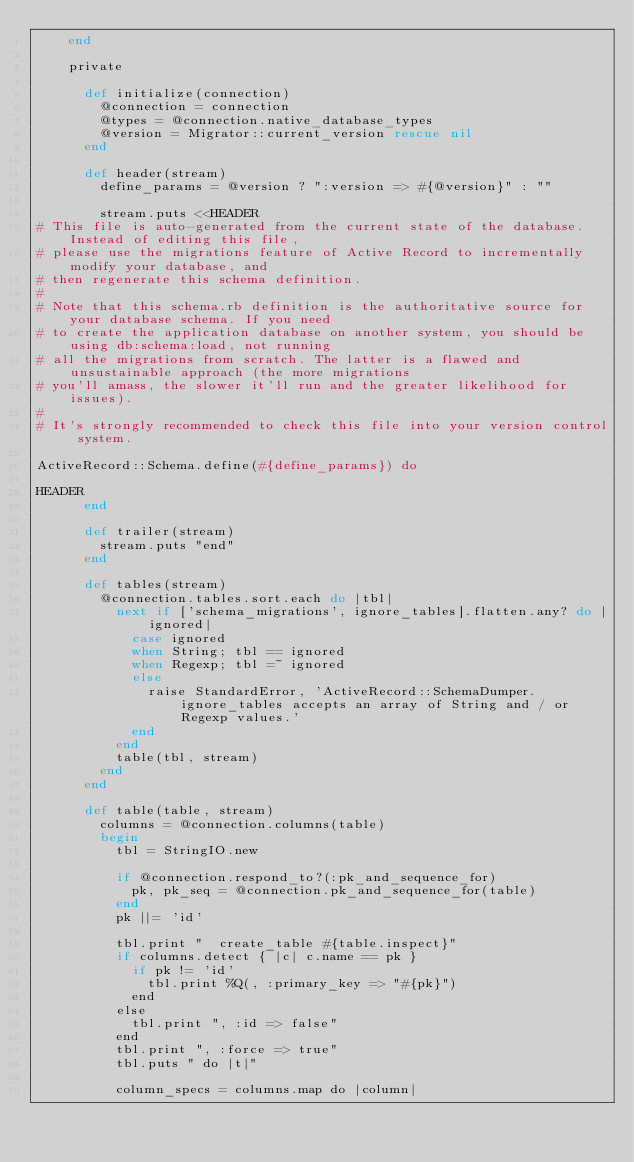Convert code to text. <code><loc_0><loc_0><loc_500><loc_500><_Ruby_>    end

    private

      def initialize(connection)
        @connection = connection
        @types = @connection.native_database_types
        @version = Migrator::current_version rescue nil
      end

      def header(stream)
        define_params = @version ? ":version => #{@version}" : ""

        stream.puts <<HEADER
# This file is auto-generated from the current state of the database. Instead of editing this file, 
# please use the migrations feature of Active Record to incrementally modify your database, and
# then regenerate this schema definition.
#
# Note that this schema.rb definition is the authoritative source for your database schema. If you need
# to create the application database on another system, you should be using db:schema:load, not running
# all the migrations from scratch. The latter is a flawed and unsustainable approach (the more migrations
# you'll amass, the slower it'll run and the greater likelihood for issues).
#
# It's strongly recommended to check this file into your version control system.

ActiveRecord::Schema.define(#{define_params}) do

HEADER
      end

      def trailer(stream)
        stream.puts "end"
      end

      def tables(stream)
        @connection.tables.sort.each do |tbl|
          next if ['schema_migrations', ignore_tables].flatten.any? do |ignored|
            case ignored
            when String; tbl == ignored
            when Regexp; tbl =~ ignored
            else
              raise StandardError, 'ActiveRecord::SchemaDumper.ignore_tables accepts an array of String and / or Regexp values.'
            end
          end 
          table(tbl, stream)
        end
      end

      def table(table, stream)
        columns = @connection.columns(table)
        begin
          tbl = StringIO.new

          if @connection.respond_to?(:pk_and_sequence_for)
            pk, pk_seq = @connection.pk_and_sequence_for(table)
          end
          pk ||= 'id'

          tbl.print "  create_table #{table.inspect}"
          if columns.detect { |c| c.name == pk }
            if pk != 'id'
              tbl.print %Q(, :primary_key => "#{pk}")
            end
          else
            tbl.print ", :id => false"
          end
          tbl.print ", :force => true"
          tbl.puts " do |t|"

          column_specs = columns.map do |column|</code> 